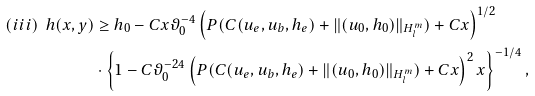Convert formula to latex. <formula><loc_0><loc_0><loc_500><loc_500>( i i i ) \ h ( x , y ) & \geq h _ { 0 } - C x \vartheta _ { 0 } ^ { - 4 } \left ( P ( C ( u _ { e } , u _ { b } , h _ { e } ) + \| ( u _ { 0 } , h _ { 0 } ) \| _ { H ^ { m } _ { l } } ) + C x \right ) ^ { 1 / 2 } \\ & \cdot \left \{ 1 - C \vartheta _ { 0 } ^ { - 2 4 } \left ( P ( C ( u _ { e } , u _ { b } , h _ { e } ) + \| ( u _ { 0 } , h _ { 0 } ) \| _ { H ^ { m } _ { l } } ) + C x \right ) ^ { 2 } x \right \} ^ { - 1 / 4 } ,</formula> 